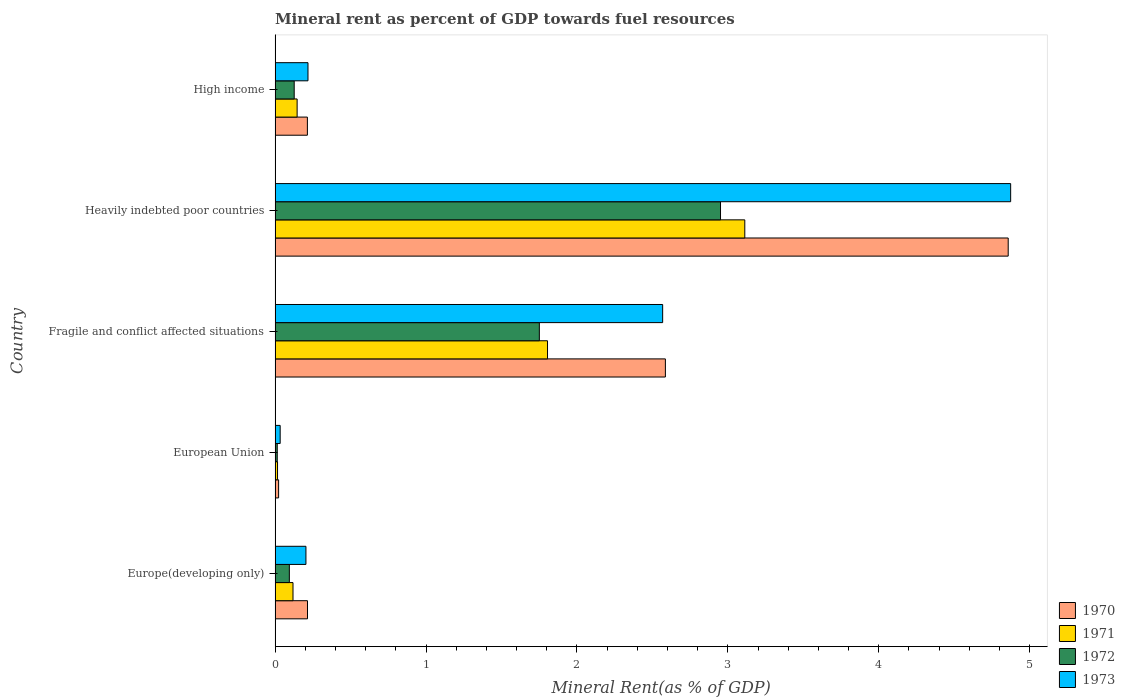Are the number of bars on each tick of the Y-axis equal?
Ensure brevity in your answer.  Yes. How many bars are there on the 4th tick from the bottom?
Give a very brief answer. 4. What is the label of the 5th group of bars from the top?
Make the answer very short. Europe(developing only). In how many cases, is the number of bars for a given country not equal to the number of legend labels?
Ensure brevity in your answer.  0. What is the mineral rent in 1970 in European Union?
Provide a short and direct response. 0.02. Across all countries, what is the maximum mineral rent in 1970?
Keep it short and to the point. 4.86. Across all countries, what is the minimum mineral rent in 1971?
Provide a succinct answer. 0.02. In which country was the mineral rent in 1970 maximum?
Keep it short and to the point. Heavily indebted poor countries. In which country was the mineral rent in 1971 minimum?
Give a very brief answer. European Union. What is the total mineral rent in 1973 in the graph?
Offer a very short reply. 7.9. What is the difference between the mineral rent in 1972 in Europe(developing only) and that in European Union?
Provide a succinct answer. 0.08. What is the difference between the mineral rent in 1971 in Fragile and conflict affected situations and the mineral rent in 1973 in European Union?
Offer a terse response. 1.77. What is the average mineral rent in 1970 per country?
Offer a terse response. 1.58. What is the difference between the mineral rent in 1971 and mineral rent in 1970 in Europe(developing only)?
Your answer should be compact. -0.1. In how many countries, is the mineral rent in 1970 greater than 0.2 %?
Ensure brevity in your answer.  4. What is the ratio of the mineral rent in 1971 in European Union to that in Heavily indebted poor countries?
Your response must be concise. 0.01. Is the mineral rent in 1973 in Europe(developing only) less than that in European Union?
Keep it short and to the point. No. Is the difference between the mineral rent in 1971 in Europe(developing only) and Fragile and conflict affected situations greater than the difference between the mineral rent in 1970 in Europe(developing only) and Fragile and conflict affected situations?
Make the answer very short. Yes. What is the difference between the highest and the second highest mineral rent in 1971?
Your answer should be very brief. 1.31. What is the difference between the highest and the lowest mineral rent in 1970?
Offer a terse response. 4.83. In how many countries, is the mineral rent in 1971 greater than the average mineral rent in 1971 taken over all countries?
Offer a very short reply. 2. Is it the case that in every country, the sum of the mineral rent in 1970 and mineral rent in 1973 is greater than the sum of mineral rent in 1971 and mineral rent in 1972?
Provide a short and direct response. No. What does the 2nd bar from the top in Fragile and conflict affected situations represents?
Your answer should be very brief. 1972. What does the 2nd bar from the bottom in Fragile and conflict affected situations represents?
Make the answer very short. 1971. Is it the case that in every country, the sum of the mineral rent in 1970 and mineral rent in 1972 is greater than the mineral rent in 1971?
Your answer should be compact. Yes. How many bars are there?
Offer a terse response. 20. Are all the bars in the graph horizontal?
Keep it short and to the point. Yes. What is the difference between two consecutive major ticks on the X-axis?
Provide a succinct answer. 1. Where does the legend appear in the graph?
Your response must be concise. Bottom right. How many legend labels are there?
Offer a terse response. 4. How are the legend labels stacked?
Your answer should be very brief. Vertical. What is the title of the graph?
Provide a succinct answer. Mineral rent as percent of GDP towards fuel resources. What is the label or title of the X-axis?
Give a very brief answer. Mineral Rent(as % of GDP). What is the Mineral Rent(as % of GDP) of 1970 in Europe(developing only)?
Keep it short and to the point. 0.21. What is the Mineral Rent(as % of GDP) of 1971 in Europe(developing only)?
Your response must be concise. 0.12. What is the Mineral Rent(as % of GDP) in 1972 in Europe(developing only)?
Offer a terse response. 0.09. What is the Mineral Rent(as % of GDP) in 1973 in Europe(developing only)?
Offer a terse response. 0.2. What is the Mineral Rent(as % of GDP) in 1970 in European Union?
Provide a succinct answer. 0.02. What is the Mineral Rent(as % of GDP) of 1971 in European Union?
Give a very brief answer. 0.02. What is the Mineral Rent(as % of GDP) of 1972 in European Union?
Provide a succinct answer. 0.01. What is the Mineral Rent(as % of GDP) in 1973 in European Union?
Provide a succinct answer. 0.03. What is the Mineral Rent(as % of GDP) of 1970 in Fragile and conflict affected situations?
Ensure brevity in your answer.  2.59. What is the Mineral Rent(as % of GDP) in 1971 in Fragile and conflict affected situations?
Offer a terse response. 1.81. What is the Mineral Rent(as % of GDP) in 1972 in Fragile and conflict affected situations?
Offer a very short reply. 1.75. What is the Mineral Rent(as % of GDP) in 1973 in Fragile and conflict affected situations?
Your response must be concise. 2.57. What is the Mineral Rent(as % of GDP) in 1970 in Heavily indebted poor countries?
Your answer should be compact. 4.86. What is the Mineral Rent(as % of GDP) in 1971 in Heavily indebted poor countries?
Your answer should be compact. 3.11. What is the Mineral Rent(as % of GDP) of 1972 in Heavily indebted poor countries?
Provide a short and direct response. 2.95. What is the Mineral Rent(as % of GDP) in 1973 in Heavily indebted poor countries?
Provide a succinct answer. 4.87. What is the Mineral Rent(as % of GDP) in 1970 in High income?
Your answer should be very brief. 0.21. What is the Mineral Rent(as % of GDP) in 1971 in High income?
Your answer should be compact. 0.15. What is the Mineral Rent(as % of GDP) of 1972 in High income?
Your answer should be compact. 0.13. What is the Mineral Rent(as % of GDP) in 1973 in High income?
Make the answer very short. 0.22. Across all countries, what is the maximum Mineral Rent(as % of GDP) of 1970?
Your answer should be compact. 4.86. Across all countries, what is the maximum Mineral Rent(as % of GDP) of 1971?
Ensure brevity in your answer.  3.11. Across all countries, what is the maximum Mineral Rent(as % of GDP) in 1972?
Make the answer very short. 2.95. Across all countries, what is the maximum Mineral Rent(as % of GDP) in 1973?
Ensure brevity in your answer.  4.87. Across all countries, what is the minimum Mineral Rent(as % of GDP) of 1970?
Your answer should be very brief. 0.02. Across all countries, what is the minimum Mineral Rent(as % of GDP) of 1971?
Keep it short and to the point. 0.02. Across all countries, what is the minimum Mineral Rent(as % of GDP) of 1972?
Offer a terse response. 0.01. Across all countries, what is the minimum Mineral Rent(as % of GDP) in 1973?
Provide a short and direct response. 0.03. What is the total Mineral Rent(as % of GDP) in 1970 in the graph?
Make the answer very short. 7.9. What is the total Mineral Rent(as % of GDP) in 1971 in the graph?
Provide a short and direct response. 5.2. What is the total Mineral Rent(as % of GDP) of 1972 in the graph?
Make the answer very short. 4.94. What is the total Mineral Rent(as % of GDP) of 1973 in the graph?
Offer a terse response. 7.9. What is the difference between the Mineral Rent(as % of GDP) of 1970 in Europe(developing only) and that in European Union?
Your response must be concise. 0.19. What is the difference between the Mineral Rent(as % of GDP) of 1971 in Europe(developing only) and that in European Union?
Ensure brevity in your answer.  0.1. What is the difference between the Mineral Rent(as % of GDP) of 1972 in Europe(developing only) and that in European Union?
Give a very brief answer. 0.08. What is the difference between the Mineral Rent(as % of GDP) in 1973 in Europe(developing only) and that in European Union?
Keep it short and to the point. 0.17. What is the difference between the Mineral Rent(as % of GDP) of 1970 in Europe(developing only) and that in Fragile and conflict affected situations?
Your response must be concise. -2.37. What is the difference between the Mineral Rent(as % of GDP) of 1971 in Europe(developing only) and that in Fragile and conflict affected situations?
Ensure brevity in your answer.  -1.69. What is the difference between the Mineral Rent(as % of GDP) in 1972 in Europe(developing only) and that in Fragile and conflict affected situations?
Offer a very short reply. -1.66. What is the difference between the Mineral Rent(as % of GDP) of 1973 in Europe(developing only) and that in Fragile and conflict affected situations?
Provide a succinct answer. -2.36. What is the difference between the Mineral Rent(as % of GDP) of 1970 in Europe(developing only) and that in Heavily indebted poor countries?
Provide a short and direct response. -4.64. What is the difference between the Mineral Rent(as % of GDP) of 1971 in Europe(developing only) and that in Heavily indebted poor countries?
Keep it short and to the point. -2.99. What is the difference between the Mineral Rent(as % of GDP) of 1972 in Europe(developing only) and that in Heavily indebted poor countries?
Offer a terse response. -2.86. What is the difference between the Mineral Rent(as % of GDP) in 1973 in Europe(developing only) and that in Heavily indebted poor countries?
Offer a very short reply. -4.67. What is the difference between the Mineral Rent(as % of GDP) of 1970 in Europe(developing only) and that in High income?
Provide a short and direct response. 0. What is the difference between the Mineral Rent(as % of GDP) in 1971 in Europe(developing only) and that in High income?
Make the answer very short. -0.03. What is the difference between the Mineral Rent(as % of GDP) in 1972 in Europe(developing only) and that in High income?
Give a very brief answer. -0.03. What is the difference between the Mineral Rent(as % of GDP) of 1973 in Europe(developing only) and that in High income?
Provide a succinct answer. -0.01. What is the difference between the Mineral Rent(as % of GDP) in 1970 in European Union and that in Fragile and conflict affected situations?
Offer a terse response. -2.56. What is the difference between the Mineral Rent(as % of GDP) in 1971 in European Union and that in Fragile and conflict affected situations?
Offer a terse response. -1.79. What is the difference between the Mineral Rent(as % of GDP) in 1972 in European Union and that in Fragile and conflict affected situations?
Make the answer very short. -1.74. What is the difference between the Mineral Rent(as % of GDP) of 1973 in European Union and that in Fragile and conflict affected situations?
Your answer should be very brief. -2.53. What is the difference between the Mineral Rent(as % of GDP) of 1970 in European Union and that in Heavily indebted poor countries?
Your answer should be compact. -4.83. What is the difference between the Mineral Rent(as % of GDP) in 1971 in European Union and that in Heavily indebted poor countries?
Give a very brief answer. -3.1. What is the difference between the Mineral Rent(as % of GDP) in 1972 in European Union and that in Heavily indebted poor countries?
Make the answer very short. -2.94. What is the difference between the Mineral Rent(as % of GDP) in 1973 in European Union and that in Heavily indebted poor countries?
Offer a very short reply. -4.84. What is the difference between the Mineral Rent(as % of GDP) in 1970 in European Union and that in High income?
Give a very brief answer. -0.19. What is the difference between the Mineral Rent(as % of GDP) in 1971 in European Union and that in High income?
Provide a succinct answer. -0.13. What is the difference between the Mineral Rent(as % of GDP) of 1972 in European Union and that in High income?
Offer a very short reply. -0.11. What is the difference between the Mineral Rent(as % of GDP) of 1973 in European Union and that in High income?
Your response must be concise. -0.18. What is the difference between the Mineral Rent(as % of GDP) of 1970 in Fragile and conflict affected situations and that in Heavily indebted poor countries?
Provide a short and direct response. -2.27. What is the difference between the Mineral Rent(as % of GDP) of 1971 in Fragile and conflict affected situations and that in Heavily indebted poor countries?
Your answer should be compact. -1.31. What is the difference between the Mineral Rent(as % of GDP) in 1972 in Fragile and conflict affected situations and that in Heavily indebted poor countries?
Provide a succinct answer. -1.2. What is the difference between the Mineral Rent(as % of GDP) of 1973 in Fragile and conflict affected situations and that in Heavily indebted poor countries?
Provide a succinct answer. -2.31. What is the difference between the Mineral Rent(as % of GDP) in 1970 in Fragile and conflict affected situations and that in High income?
Keep it short and to the point. 2.37. What is the difference between the Mineral Rent(as % of GDP) of 1971 in Fragile and conflict affected situations and that in High income?
Provide a succinct answer. 1.66. What is the difference between the Mineral Rent(as % of GDP) in 1972 in Fragile and conflict affected situations and that in High income?
Your response must be concise. 1.62. What is the difference between the Mineral Rent(as % of GDP) of 1973 in Fragile and conflict affected situations and that in High income?
Provide a short and direct response. 2.35. What is the difference between the Mineral Rent(as % of GDP) of 1970 in Heavily indebted poor countries and that in High income?
Make the answer very short. 4.64. What is the difference between the Mineral Rent(as % of GDP) of 1971 in Heavily indebted poor countries and that in High income?
Offer a terse response. 2.97. What is the difference between the Mineral Rent(as % of GDP) in 1972 in Heavily indebted poor countries and that in High income?
Your response must be concise. 2.82. What is the difference between the Mineral Rent(as % of GDP) in 1973 in Heavily indebted poor countries and that in High income?
Your answer should be very brief. 4.66. What is the difference between the Mineral Rent(as % of GDP) in 1970 in Europe(developing only) and the Mineral Rent(as % of GDP) in 1971 in European Union?
Offer a very short reply. 0.2. What is the difference between the Mineral Rent(as % of GDP) in 1970 in Europe(developing only) and the Mineral Rent(as % of GDP) in 1972 in European Union?
Ensure brevity in your answer.  0.2. What is the difference between the Mineral Rent(as % of GDP) in 1970 in Europe(developing only) and the Mineral Rent(as % of GDP) in 1973 in European Union?
Your answer should be very brief. 0.18. What is the difference between the Mineral Rent(as % of GDP) of 1971 in Europe(developing only) and the Mineral Rent(as % of GDP) of 1972 in European Union?
Provide a succinct answer. 0.1. What is the difference between the Mineral Rent(as % of GDP) in 1971 in Europe(developing only) and the Mineral Rent(as % of GDP) in 1973 in European Union?
Ensure brevity in your answer.  0.09. What is the difference between the Mineral Rent(as % of GDP) of 1972 in Europe(developing only) and the Mineral Rent(as % of GDP) of 1973 in European Union?
Your answer should be compact. 0.06. What is the difference between the Mineral Rent(as % of GDP) in 1970 in Europe(developing only) and the Mineral Rent(as % of GDP) in 1971 in Fragile and conflict affected situations?
Provide a short and direct response. -1.59. What is the difference between the Mineral Rent(as % of GDP) of 1970 in Europe(developing only) and the Mineral Rent(as % of GDP) of 1972 in Fragile and conflict affected situations?
Provide a succinct answer. -1.54. What is the difference between the Mineral Rent(as % of GDP) of 1970 in Europe(developing only) and the Mineral Rent(as % of GDP) of 1973 in Fragile and conflict affected situations?
Give a very brief answer. -2.35. What is the difference between the Mineral Rent(as % of GDP) of 1971 in Europe(developing only) and the Mineral Rent(as % of GDP) of 1972 in Fragile and conflict affected situations?
Offer a terse response. -1.63. What is the difference between the Mineral Rent(as % of GDP) in 1971 in Europe(developing only) and the Mineral Rent(as % of GDP) in 1973 in Fragile and conflict affected situations?
Ensure brevity in your answer.  -2.45. What is the difference between the Mineral Rent(as % of GDP) of 1972 in Europe(developing only) and the Mineral Rent(as % of GDP) of 1973 in Fragile and conflict affected situations?
Keep it short and to the point. -2.47. What is the difference between the Mineral Rent(as % of GDP) in 1970 in Europe(developing only) and the Mineral Rent(as % of GDP) in 1971 in Heavily indebted poor countries?
Your answer should be compact. -2.9. What is the difference between the Mineral Rent(as % of GDP) of 1970 in Europe(developing only) and the Mineral Rent(as % of GDP) of 1972 in Heavily indebted poor countries?
Keep it short and to the point. -2.74. What is the difference between the Mineral Rent(as % of GDP) in 1970 in Europe(developing only) and the Mineral Rent(as % of GDP) in 1973 in Heavily indebted poor countries?
Your answer should be very brief. -4.66. What is the difference between the Mineral Rent(as % of GDP) in 1971 in Europe(developing only) and the Mineral Rent(as % of GDP) in 1972 in Heavily indebted poor countries?
Your response must be concise. -2.83. What is the difference between the Mineral Rent(as % of GDP) of 1971 in Europe(developing only) and the Mineral Rent(as % of GDP) of 1973 in Heavily indebted poor countries?
Keep it short and to the point. -4.76. What is the difference between the Mineral Rent(as % of GDP) of 1972 in Europe(developing only) and the Mineral Rent(as % of GDP) of 1973 in Heavily indebted poor countries?
Keep it short and to the point. -4.78. What is the difference between the Mineral Rent(as % of GDP) of 1970 in Europe(developing only) and the Mineral Rent(as % of GDP) of 1971 in High income?
Provide a succinct answer. 0.07. What is the difference between the Mineral Rent(as % of GDP) of 1970 in Europe(developing only) and the Mineral Rent(as % of GDP) of 1972 in High income?
Offer a terse response. 0.09. What is the difference between the Mineral Rent(as % of GDP) in 1970 in Europe(developing only) and the Mineral Rent(as % of GDP) in 1973 in High income?
Ensure brevity in your answer.  -0. What is the difference between the Mineral Rent(as % of GDP) in 1971 in Europe(developing only) and the Mineral Rent(as % of GDP) in 1972 in High income?
Keep it short and to the point. -0.01. What is the difference between the Mineral Rent(as % of GDP) in 1971 in Europe(developing only) and the Mineral Rent(as % of GDP) in 1973 in High income?
Give a very brief answer. -0.1. What is the difference between the Mineral Rent(as % of GDP) in 1972 in Europe(developing only) and the Mineral Rent(as % of GDP) in 1973 in High income?
Provide a succinct answer. -0.12. What is the difference between the Mineral Rent(as % of GDP) of 1970 in European Union and the Mineral Rent(as % of GDP) of 1971 in Fragile and conflict affected situations?
Offer a terse response. -1.78. What is the difference between the Mineral Rent(as % of GDP) of 1970 in European Union and the Mineral Rent(as % of GDP) of 1972 in Fragile and conflict affected situations?
Keep it short and to the point. -1.73. What is the difference between the Mineral Rent(as % of GDP) in 1970 in European Union and the Mineral Rent(as % of GDP) in 1973 in Fragile and conflict affected situations?
Ensure brevity in your answer.  -2.54. What is the difference between the Mineral Rent(as % of GDP) in 1971 in European Union and the Mineral Rent(as % of GDP) in 1972 in Fragile and conflict affected situations?
Offer a terse response. -1.73. What is the difference between the Mineral Rent(as % of GDP) of 1971 in European Union and the Mineral Rent(as % of GDP) of 1973 in Fragile and conflict affected situations?
Provide a succinct answer. -2.55. What is the difference between the Mineral Rent(as % of GDP) of 1972 in European Union and the Mineral Rent(as % of GDP) of 1973 in Fragile and conflict affected situations?
Give a very brief answer. -2.55. What is the difference between the Mineral Rent(as % of GDP) in 1970 in European Union and the Mineral Rent(as % of GDP) in 1971 in Heavily indebted poor countries?
Your response must be concise. -3.09. What is the difference between the Mineral Rent(as % of GDP) of 1970 in European Union and the Mineral Rent(as % of GDP) of 1972 in Heavily indebted poor countries?
Provide a succinct answer. -2.93. What is the difference between the Mineral Rent(as % of GDP) of 1970 in European Union and the Mineral Rent(as % of GDP) of 1973 in Heavily indebted poor countries?
Your answer should be compact. -4.85. What is the difference between the Mineral Rent(as % of GDP) in 1971 in European Union and the Mineral Rent(as % of GDP) in 1972 in Heavily indebted poor countries?
Your response must be concise. -2.94. What is the difference between the Mineral Rent(as % of GDP) of 1971 in European Union and the Mineral Rent(as % of GDP) of 1973 in Heavily indebted poor countries?
Make the answer very short. -4.86. What is the difference between the Mineral Rent(as % of GDP) in 1972 in European Union and the Mineral Rent(as % of GDP) in 1973 in Heavily indebted poor countries?
Your response must be concise. -4.86. What is the difference between the Mineral Rent(as % of GDP) in 1970 in European Union and the Mineral Rent(as % of GDP) in 1971 in High income?
Your answer should be compact. -0.12. What is the difference between the Mineral Rent(as % of GDP) of 1970 in European Union and the Mineral Rent(as % of GDP) of 1972 in High income?
Keep it short and to the point. -0.1. What is the difference between the Mineral Rent(as % of GDP) of 1970 in European Union and the Mineral Rent(as % of GDP) of 1973 in High income?
Your answer should be very brief. -0.19. What is the difference between the Mineral Rent(as % of GDP) in 1971 in European Union and the Mineral Rent(as % of GDP) in 1972 in High income?
Your response must be concise. -0.11. What is the difference between the Mineral Rent(as % of GDP) in 1971 in European Union and the Mineral Rent(as % of GDP) in 1973 in High income?
Offer a terse response. -0.2. What is the difference between the Mineral Rent(as % of GDP) of 1972 in European Union and the Mineral Rent(as % of GDP) of 1973 in High income?
Offer a terse response. -0.2. What is the difference between the Mineral Rent(as % of GDP) in 1970 in Fragile and conflict affected situations and the Mineral Rent(as % of GDP) in 1971 in Heavily indebted poor countries?
Keep it short and to the point. -0.53. What is the difference between the Mineral Rent(as % of GDP) of 1970 in Fragile and conflict affected situations and the Mineral Rent(as % of GDP) of 1972 in Heavily indebted poor countries?
Offer a very short reply. -0.37. What is the difference between the Mineral Rent(as % of GDP) of 1970 in Fragile and conflict affected situations and the Mineral Rent(as % of GDP) of 1973 in Heavily indebted poor countries?
Keep it short and to the point. -2.29. What is the difference between the Mineral Rent(as % of GDP) of 1971 in Fragile and conflict affected situations and the Mineral Rent(as % of GDP) of 1972 in Heavily indebted poor countries?
Your response must be concise. -1.15. What is the difference between the Mineral Rent(as % of GDP) in 1971 in Fragile and conflict affected situations and the Mineral Rent(as % of GDP) in 1973 in Heavily indebted poor countries?
Ensure brevity in your answer.  -3.07. What is the difference between the Mineral Rent(as % of GDP) in 1972 in Fragile and conflict affected situations and the Mineral Rent(as % of GDP) in 1973 in Heavily indebted poor countries?
Make the answer very short. -3.12. What is the difference between the Mineral Rent(as % of GDP) of 1970 in Fragile and conflict affected situations and the Mineral Rent(as % of GDP) of 1971 in High income?
Your answer should be very brief. 2.44. What is the difference between the Mineral Rent(as % of GDP) in 1970 in Fragile and conflict affected situations and the Mineral Rent(as % of GDP) in 1972 in High income?
Your response must be concise. 2.46. What is the difference between the Mineral Rent(as % of GDP) of 1970 in Fragile and conflict affected situations and the Mineral Rent(as % of GDP) of 1973 in High income?
Make the answer very short. 2.37. What is the difference between the Mineral Rent(as % of GDP) in 1971 in Fragile and conflict affected situations and the Mineral Rent(as % of GDP) in 1972 in High income?
Keep it short and to the point. 1.68. What is the difference between the Mineral Rent(as % of GDP) in 1971 in Fragile and conflict affected situations and the Mineral Rent(as % of GDP) in 1973 in High income?
Offer a very short reply. 1.59. What is the difference between the Mineral Rent(as % of GDP) in 1972 in Fragile and conflict affected situations and the Mineral Rent(as % of GDP) in 1973 in High income?
Offer a very short reply. 1.53. What is the difference between the Mineral Rent(as % of GDP) of 1970 in Heavily indebted poor countries and the Mineral Rent(as % of GDP) of 1971 in High income?
Give a very brief answer. 4.71. What is the difference between the Mineral Rent(as % of GDP) of 1970 in Heavily indebted poor countries and the Mineral Rent(as % of GDP) of 1972 in High income?
Your response must be concise. 4.73. What is the difference between the Mineral Rent(as % of GDP) of 1970 in Heavily indebted poor countries and the Mineral Rent(as % of GDP) of 1973 in High income?
Ensure brevity in your answer.  4.64. What is the difference between the Mineral Rent(as % of GDP) of 1971 in Heavily indebted poor countries and the Mineral Rent(as % of GDP) of 1972 in High income?
Your answer should be very brief. 2.99. What is the difference between the Mineral Rent(as % of GDP) of 1971 in Heavily indebted poor countries and the Mineral Rent(as % of GDP) of 1973 in High income?
Provide a short and direct response. 2.89. What is the difference between the Mineral Rent(as % of GDP) of 1972 in Heavily indebted poor countries and the Mineral Rent(as % of GDP) of 1973 in High income?
Provide a succinct answer. 2.73. What is the average Mineral Rent(as % of GDP) in 1970 per country?
Make the answer very short. 1.58. What is the average Mineral Rent(as % of GDP) of 1971 per country?
Your response must be concise. 1.04. What is the average Mineral Rent(as % of GDP) in 1972 per country?
Offer a terse response. 0.99. What is the average Mineral Rent(as % of GDP) of 1973 per country?
Make the answer very short. 1.58. What is the difference between the Mineral Rent(as % of GDP) in 1970 and Mineral Rent(as % of GDP) in 1971 in Europe(developing only)?
Keep it short and to the point. 0.1. What is the difference between the Mineral Rent(as % of GDP) in 1970 and Mineral Rent(as % of GDP) in 1972 in Europe(developing only)?
Keep it short and to the point. 0.12. What is the difference between the Mineral Rent(as % of GDP) in 1970 and Mineral Rent(as % of GDP) in 1973 in Europe(developing only)?
Provide a short and direct response. 0.01. What is the difference between the Mineral Rent(as % of GDP) of 1971 and Mineral Rent(as % of GDP) of 1972 in Europe(developing only)?
Offer a terse response. 0.02. What is the difference between the Mineral Rent(as % of GDP) in 1971 and Mineral Rent(as % of GDP) in 1973 in Europe(developing only)?
Provide a short and direct response. -0.09. What is the difference between the Mineral Rent(as % of GDP) in 1972 and Mineral Rent(as % of GDP) in 1973 in Europe(developing only)?
Offer a very short reply. -0.11. What is the difference between the Mineral Rent(as % of GDP) of 1970 and Mineral Rent(as % of GDP) of 1971 in European Union?
Make the answer very short. 0.01. What is the difference between the Mineral Rent(as % of GDP) in 1970 and Mineral Rent(as % of GDP) in 1972 in European Union?
Your response must be concise. 0.01. What is the difference between the Mineral Rent(as % of GDP) of 1970 and Mineral Rent(as % of GDP) of 1973 in European Union?
Give a very brief answer. -0.01. What is the difference between the Mineral Rent(as % of GDP) of 1971 and Mineral Rent(as % of GDP) of 1972 in European Union?
Your answer should be compact. 0. What is the difference between the Mineral Rent(as % of GDP) of 1971 and Mineral Rent(as % of GDP) of 1973 in European Union?
Keep it short and to the point. -0.02. What is the difference between the Mineral Rent(as % of GDP) of 1972 and Mineral Rent(as % of GDP) of 1973 in European Union?
Provide a short and direct response. -0.02. What is the difference between the Mineral Rent(as % of GDP) of 1970 and Mineral Rent(as % of GDP) of 1971 in Fragile and conflict affected situations?
Keep it short and to the point. 0.78. What is the difference between the Mineral Rent(as % of GDP) of 1970 and Mineral Rent(as % of GDP) of 1972 in Fragile and conflict affected situations?
Provide a short and direct response. 0.84. What is the difference between the Mineral Rent(as % of GDP) in 1970 and Mineral Rent(as % of GDP) in 1973 in Fragile and conflict affected situations?
Your answer should be compact. 0.02. What is the difference between the Mineral Rent(as % of GDP) of 1971 and Mineral Rent(as % of GDP) of 1972 in Fragile and conflict affected situations?
Make the answer very short. 0.05. What is the difference between the Mineral Rent(as % of GDP) of 1971 and Mineral Rent(as % of GDP) of 1973 in Fragile and conflict affected situations?
Your answer should be compact. -0.76. What is the difference between the Mineral Rent(as % of GDP) of 1972 and Mineral Rent(as % of GDP) of 1973 in Fragile and conflict affected situations?
Your answer should be very brief. -0.82. What is the difference between the Mineral Rent(as % of GDP) of 1970 and Mineral Rent(as % of GDP) of 1971 in Heavily indebted poor countries?
Offer a very short reply. 1.75. What is the difference between the Mineral Rent(as % of GDP) in 1970 and Mineral Rent(as % of GDP) in 1972 in Heavily indebted poor countries?
Your answer should be very brief. 1.91. What is the difference between the Mineral Rent(as % of GDP) in 1970 and Mineral Rent(as % of GDP) in 1973 in Heavily indebted poor countries?
Offer a terse response. -0.02. What is the difference between the Mineral Rent(as % of GDP) of 1971 and Mineral Rent(as % of GDP) of 1972 in Heavily indebted poor countries?
Provide a short and direct response. 0.16. What is the difference between the Mineral Rent(as % of GDP) of 1971 and Mineral Rent(as % of GDP) of 1973 in Heavily indebted poor countries?
Keep it short and to the point. -1.76. What is the difference between the Mineral Rent(as % of GDP) of 1972 and Mineral Rent(as % of GDP) of 1973 in Heavily indebted poor countries?
Ensure brevity in your answer.  -1.92. What is the difference between the Mineral Rent(as % of GDP) of 1970 and Mineral Rent(as % of GDP) of 1971 in High income?
Ensure brevity in your answer.  0.07. What is the difference between the Mineral Rent(as % of GDP) of 1970 and Mineral Rent(as % of GDP) of 1972 in High income?
Ensure brevity in your answer.  0.09. What is the difference between the Mineral Rent(as % of GDP) in 1970 and Mineral Rent(as % of GDP) in 1973 in High income?
Keep it short and to the point. -0. What is the difference between the Mineral Rent(as % of GDP) of 1971 and Mineral Rent(as % of GDP) of 1972 in High income?
Give a very brief answer. 0.02. What is the difference between the Mineral Rent(as % of GDP) of 1971 and Mineral Rent(as % of GDP) of 1973 in High income?
Provide a succinct answer. -0.07. What is the difference between the Mineral Rent(as % of GDP) of 1972 and Mineral Rent(as % of GDP) of 1973 in High income?
Ensure brevity in your answer.  -0.09. What is the ratio of the Mineral Rent(as % of GDP) of 1970 in Europe(developing only) to that in European Union?
Offer a very short reply. 9.2. What is the ratio of the Mineral Rent(as % of GDP) of 1971 in Europe(developing only) to that in European Union?
Your answer should be very brief. 7.31. What is the ratio of the Mineral Rent(as % of GDP) of 1972 in Europe(developing only) to that in European Union?
Your response must be concise. 6.59. What is the ratio of the Mineral Rent(as % of GDP) in 1973 in Europe(developing only) to that in European Union?
Offer a terse response. 6.06. What is the ratio of the Mineral Rent(as % of GDP) in 1970 in Europe(developing only) to that in Fragile and conflict affected situations?
Offer a very short reply. 0.08. What is the ratio of the Mineral Rent(as % of GDP) of 1971 in Europe(developing only) to that in Fragile and conflict affected situations?
Ensure brevity in your answer.  0.07. What is the ratio of the Mineral Rent(as % of GDP) in 1972 in Europe(developing only) to that in Fragile and conflict affected situations?
Give a very brief answer. 0.05. What is the ratio of the Mineral Rent(as % of GDP) in 1973 in Europe(developing only) to that in Fragile and conflict affected situations?
Provide a short and direct response. 0.08. What is the ratio of the Mineral Rent(as % of GDP) of 1970 in Europe(developing only) to that in Heavily indebted poor countries?
Your response must be concise. 0.04. What is the ratio of the Mineral Rent(as % of GDP) in 1971 in Europe(developing only) to that in Heavily indebted poor countries?
Your answer should be compact. 0.04. What is the ratio of the Mineral Rent(as % of GDP) of 1972 in Europe(developing only) to that in Heavily indebted poor countries?
Keep it short and to the point. 0.03. What is the ratio of the Mineral Rent(as % of GDP) in 1973 in Europe(developing only) to that in Heavily indebted poor countries?
Offer a very short reply. 0.04. What is the ratio of the Mineral Rent(as % of GDP) in 1971 in Europe(developing only) to that in High income?
Ensure brevity in your answer.  0.81. What is the ratio of the Mineral Rent(as % of GDP) of 1972 in Europe(developing only) to that in High income?
Your answer should be very brief. 0.75. What is the ratio of the Mineral Rent(as % of GDP) in 1973 in Europe(developing only) to that in High income?
Ensure brevity in your answer.  0.94. What is the ratio of the Mineral Rent(as % of GDP) in 1970 in European Union to that in Fragile and conflict affected situations?
Your answer should be compact. 0.01. What is the ratio of the Mineral Rent(as % of GDP) of 1971 in European Union to that in Fragile and conflict affected situations?
Provide a succinct answer. 0.01. What is the ratio of the Mineral Rent(as % of GDP) in 1972 in European Union to that in Fragile and conflict affected situations?
Offer a terse response. 0.01. What is the ratio of the Mineral Rent(as % of GDP) of 1973 in European Union to that in Fragile and conflict affected situations?
Make the answer very short. 0.01. What is the ratio of the Mineral Rent(as % of GDP) of 1970 in European Union to that in Heavily indebted poor countries?
Your response must be concise. 0. What is the ratio of the Mineral Rent(as % of GDP) of 1971 in European Union to that in Heavily indebted poor countries?
Provide a succinct answer. 0.01. What is the ratio of the Mineral Rent(as % of GDP) of 1972 in European Union to that in Heavily indebted poor countries?
Offer a terse response. 0. What is the ratio of the Mineral Rent(as % of GDP) in 1973 in European Union to that in Heavily indebted poor countries?
Your answer should be compact. 0.01. What is the ratio of the Mineral Rent(as % of GDP) in 1970 in European Union to that in High income?
Make the answer very short. 0.11. What is the ratio of the Mineral Rent(as % of GDP) in 1971 in European Union to that in High income?
Ensure brevity in your answer.  0.11. What is the ratio of the Mineral Rent(as % of GDP) in 1972 in European Union to that in High income?
Your response must be concise. 0.11. What is the ratio of the Mineral Rent(as % of GDP) in 1973 in European Union to that in High income?
Your response must be concise. 0.15. What is the ratio of the Mineral Rent(as % of GDP) of 1970 in Fragile and conflict affected situations to that in Heavily indebted poor countries?
Your answer should be very brief. 0.53. What is the ratio of the Mineral Rent(as % of GDP) of 1971 in Fragile and conflict affected situations to that in Heavily indebted poor countries?
Keep it short and to the point. 0.58. What is the ratio of the Mineral Rent(as % of GDP) of 1972 in Fragile and conflict affected situations to that in Heavily indebted poor countries?
Offer a terse response. 0.59. What is the ratio of the Mineral Rent(as % of GDP) in 1973 in Fragile and conflict affected situations to that in Heavily indebted poor countries?
Your response must be concise. 0.53. What is the ratio of the Mineral Rent(as % of GDP) of 1970 in Fragile and conflict affected situations to that in High income?
Give a very brief answer. 12.08. What is the ratio of the Mineral Rent(as % of GDP) of 1971 in Fragile and conflict affected situations to that in High income?
Your answer should be compact. 12.36. What is the ratio of the Mineral Rent(as % of GDP) of 1972 in Fragile and conflict affected situations to that in High income?
Your response must be concise. 13.82. What is the ratio of the Mineral Rent(as % of GDP) of 1973 in Fragile and conflict affected situations to that in High income?
Offer a very short reply. 11.78. What is the ratio of the Mineral Rent(as % of GDP) of 1970 in Heavily indebted poor countries to that in High income?
Provide a short and direct response. 22.69. What is the ratio of the Mineral Rent(as % of GDP) of 1971 in Heavily indebted poor countries to that in High income?
Your answer should be compact. 21.31. What is the ratio of the Mineral Rent(as % of GDP) of 1972 in Heavily indebted poor countries to that in High income?
Ensure brevity in your answer.  23.3. What is the ratio of the Mineral Rent(as % of GDP) in 1973 in Heavily indebted poor countries to that in High income?
Your answer should be compact. 22.35. What is the difference between the highest and the second highest Mineral Rent(as % of GDP) of 1970?
Provide a succinct answer. 2.27. What is the difference between the highest and the second highest Mineral Rent(as % of GDP) in 1971?
Offer a terse response. 1.31. What is the difference between the highest and the second highest Mineral Rent(as % of GDP) in 1972?
Your answer should be compact. 1.2. What is the difference between the highest and the second highest Mineral Rent(as % of GDP) in 1973?
Provide a succinct answer. 2.31. What is the difference between the highest and the lowest Mineral Rent(as % of GDP) of 1970?
Provide a succinct answer. 4.83. What is the difference between the highest and the lowest Mineral Rent(as % of GDP) of 1971?
Offer a very short reply. 3.1. What is the difference between the highest and the lowest Mineral Rent(as % of GDP) of 1972?
Provide a succinct answer. 2.94. What is the difference between the highest and the lowest Mineral Rent(as % of GDP) in 1973?
Offer a very short reply. 4.84. 